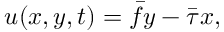<formula> <loc_0><loc_0><loc_500><loc_500>{ u } ( x , y , t ) = \bar { f } y - \bar { \tau } x ,</formula> 